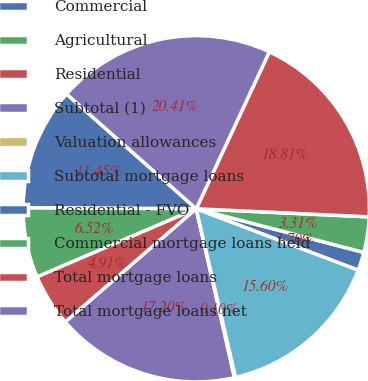<chart> <loc_0><loc_0><loc_500><loc_500><pie_chart><fcel>Commercial<fcel>Agricultural<fcel>Residential<fcel>Subtotal (1)<fcel>Valuation allowances<fcel>Subtotal mortgage loans<fcel>Residential - FVO<fcel>Commercial mortgage loans held<fcel>Total mortgage loans<fcel>Total mortgage loans net<nl><fcel>11.45%<fcel>6.52%<fcel>4.91%<fcel>17.2%<fcel>0.1%<fcel>15.6%<fcel>1.7%<fcel>3.31%<fcel>18.81%<fcel>20.41%<nl></chart> 